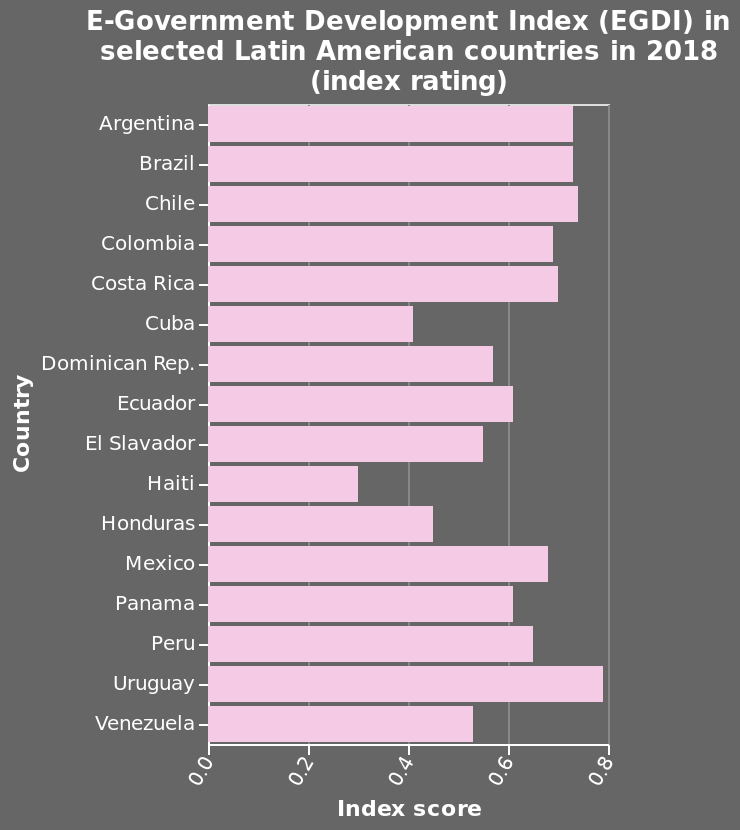<image>
What does the y-axis of the diagram represent? The y-axis represents the countries in Latin America, ranging from Argentina to Venezuela. Which country has the highest EDGI index? Uruguay has the highest EDGI index. 